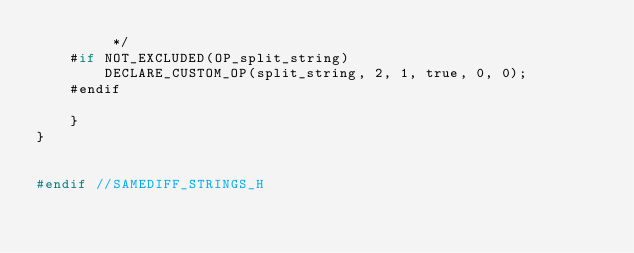Convert code to text. <code><loc_0><loc_0><loc_500><loc_500><_C_>         */
    #if NOT_EXCLUDED(OP_split_string)
        DECLARE_CUSTOM_OP(split_string, 2, 1, true, 0, 0);
    #endif

    }
}


#endif //SAMEDIFF_STRINGS_H
</code> 